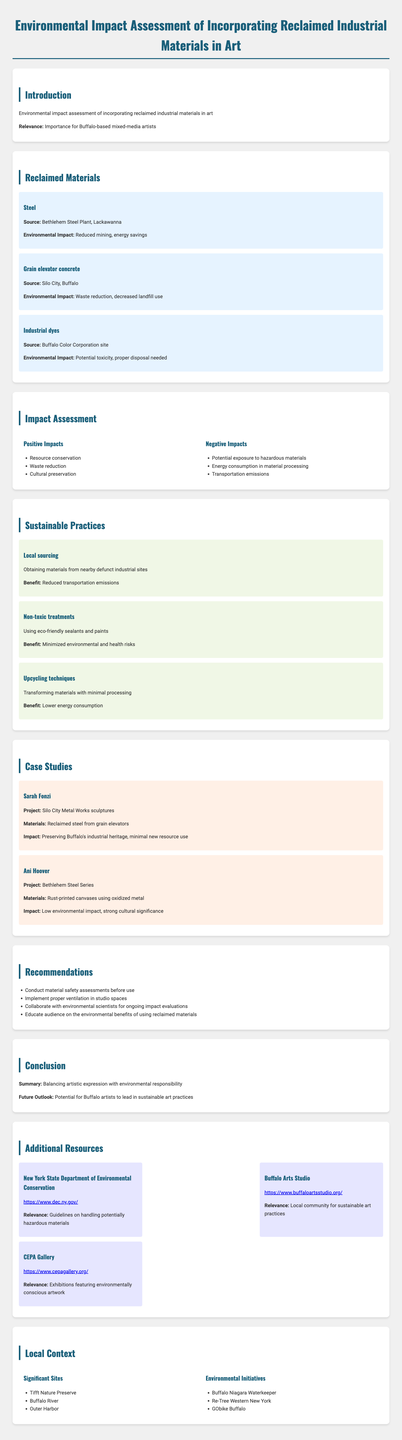what is the purpose of the report? The purpose of the report is to assess the environmental impact of incorporating reclaimed industrial materials in art.
Answer: assess the environmental impact which reclaimed material comes from Silo City? Silo City provides grain elevator concrete as a reclaimed material.
Answer: grain elevator concrete name one positive impact of using reclaimed materials. The report lists several positive impacts, one of which is resource conservation.
Answer: resource conservation what is one recommendation made for artists? One of the recommendations is to conduct material safety assessments before use.
Answer: conduct material safety assessments who created the Bethlehem Steel Series project? The Bethlehem Steel Series project was created by artist Ani Hoover.
Answer: Ani Hoover how many sustainable practices are discussed in the document? The document outlines three sustainable practices for artists.
Answer: three what are the significant sites mentioned in the local context? Significant sites include Tifft Nature Preserve, Buffalo River, and Outer Harbor.
Answer: Tifft Nature Preserve, Buffalo River, Outer Harbor what is the relevance of the report to Buffalo-based artists? The report emphasizes the importance for Buffalo-based mixed-media artists in their artistic practices.
Answer: importance for Buffalo-based mixed-media artists name an environmental initiative mentioned in the document. One of the environmental initiatives mentioned is Buffalo Niagara Waterkeeper.
Answer: Buffalo Niagara Waterkeeper 